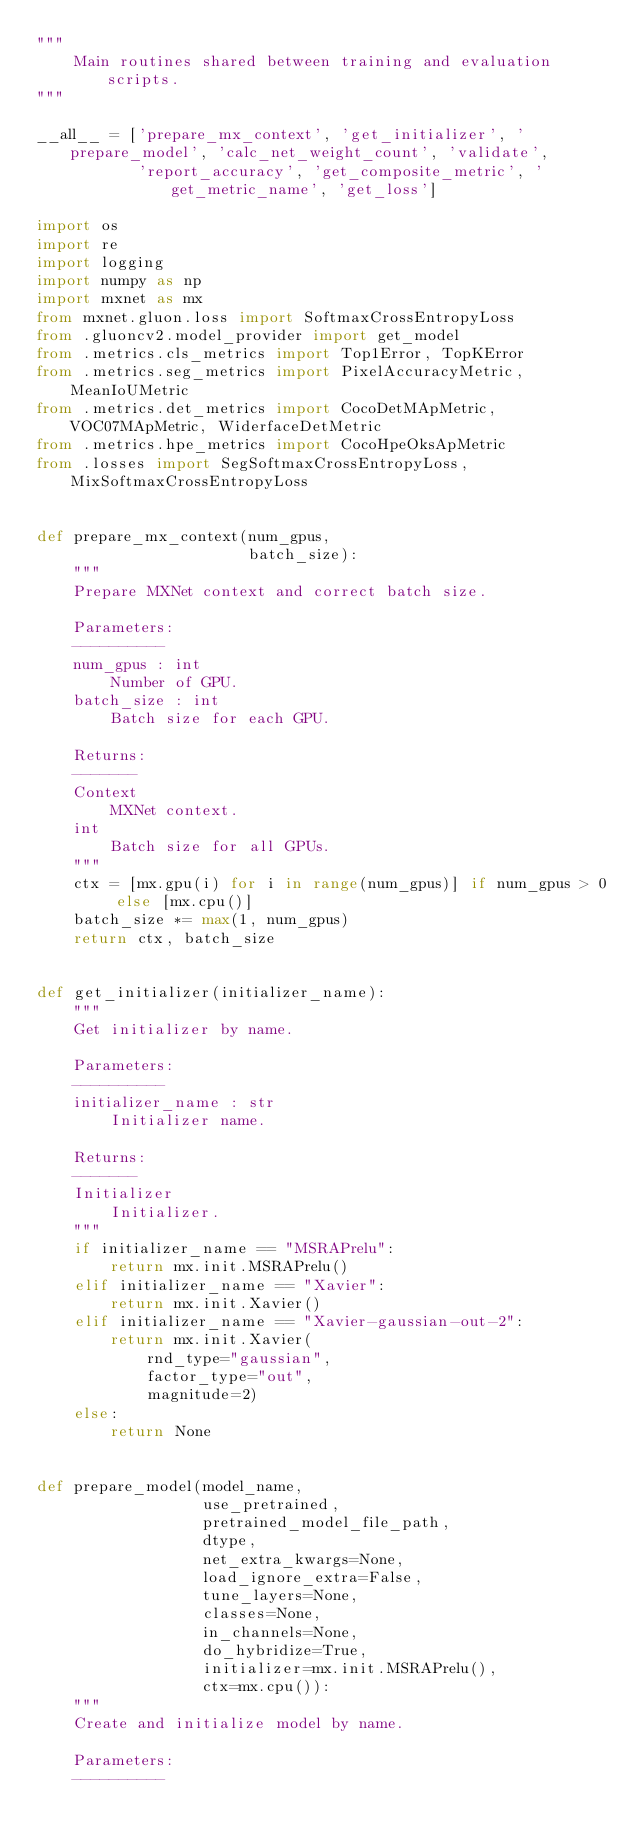<code> <loc_0><loc_0><loc_500><loc_500><_Python_>"""
    Main routines shared between training and evaluation scripts.
"""

__all__ = ['prepare_mx_context', 'get_initializer', 'prepare_model', 'calc_net_weight_count', 'validate',
           'report_accuracy', 'get_composite_metric', 'get_metric_name', 'get_loss']

import os
import re
import logging
import numpy as np
import mxnet as mx
from mxnet.gluon.loss import SoftmaxCrossEntropyLoss
from .gluoncv2.model_provider import get_model
from .metrics.cls_metrics import Top1Error, TopKError
from .metrics.seg_metrics import PixelAccuracyMetric, MeanIoUMetric
from .metrics.det_metrics import CocoDetMApMetric, VOC07MApMetric, WiderfaceDetMetric
from .metrics.hpe_metrics import CocoHpeOksApMetric
from .losses import SegSoftmaxCrossEntropyLoss, MixSoftmaxCrossEntropyLoss


def prepare_mx_context(num_gpus,
                       batch_size):
    """
    Prepare MXNet context and correct batch size.

    Parameters:
    ----------
    num_gpus : int
        Number of GPU.
    batch_size : int
        Batch size for each GPU.

    Returns:
    -------
    Context
        MXNet context.
    int
        Batch size for all GPUs.
    """
    ctx = [mx.gpu(i) for i in range(num_gpus)] if num_gpus > 0 else [mx.cpu()]
    batch_size *= max(1, num_gpus)
    return ctx, batch_size


def get_initializer(initializer_name):
    """
    Get initializer by name.

    Parameters:
    ----------
    initializer_name : str
        Initializer name.

    Returns:
    -------
    Initializer
        Initializer.
    """
    if initializer_name == "MSRAPrelu":
        return mx.init.MSRAPrelu()
    elif initializer_name == "Xavier":
        return mx.init.Xavier()
    elif initializer_name == "Xavier-gaussian-out-2":
        return mx.init.Xavier(
            rnd_type="gaussian",
            factor_type="out",
            magnitude=2)
    else:
        return None


def prepare_model(model_name,
                  use_pretrained,
                  pretrained_model_file_path,
                  dtype,
                  net_extra_kwargs=None,
                  load_ignore_extra=False,
                  tune_layers=None,
                  classes=None,
                  in_channels=None,
                  do_hybridize=True,
                  initializer=mx.init.MSRAPrelu(),
                  ctx=mx.cpu()):
    """
    Create and initialize model by name.

    Parameters:
    ----------</code> 